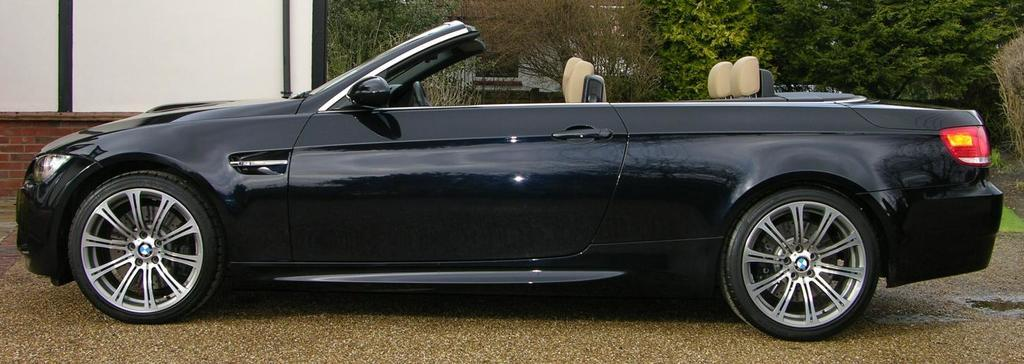What type of vehicle is in the image? There is a black car in the image. Where is the car located in relation to other objects? The car is near a wall in the image. What can be seen behind the trees in the image? There is a house behind the trees in the image. What is attached to the white wall in the image? There are poles attached to the white wall in the image. What type of vegetation is present in the image? There are trees, bushes, plants, and grass in the image. Where is the writer sitting on the throne in the image? There is no writer or throne present in the image. What type of shelter is set up in the image? There is no tent or any other type of shelter present in the image. 